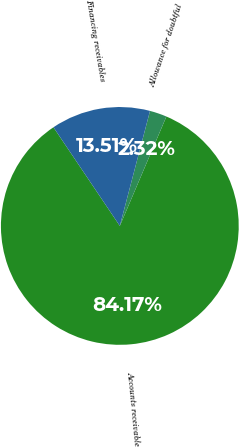Convert chart to OTSL. <chart><loc_0><loc_0><loc_500><loc_500><pie_chart><fcel>Accounts receivable<fcel>Allowance for doubtful<fcel>Financing receivables<nl><fcel>84.17%<fcel>2.32%<fcel>13.51%<nl></chart> 